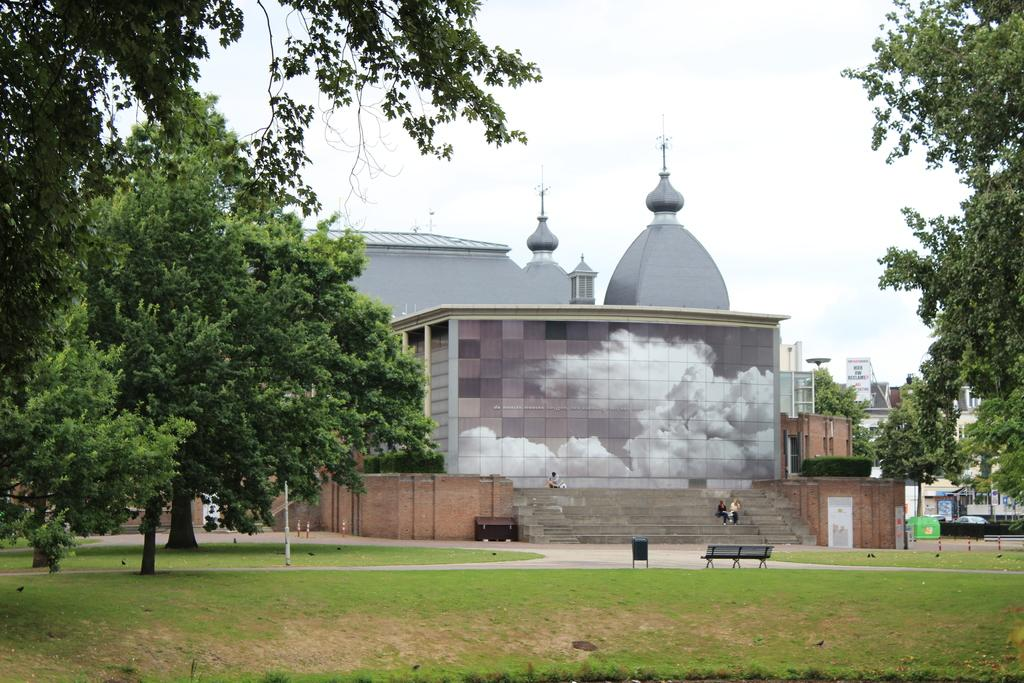What type of landscape is in the front of the image? There is a grassland in the front of the image. What can be seen on either side of the grassland? There are trees on either side of the grassland. What structure is located in the back of the image? There is a palace in the back of the image. What else can be seen behind the palace? There are buildings behind the palace. What is visible above the palace? The sky is visible above the palace. What type of alarm is ringing in the image? There is no alarm present in the image. Can you describe the haircut of the person standing in front of the palace? There is no person visible in the image, so it is impossible to describe their haircut. 